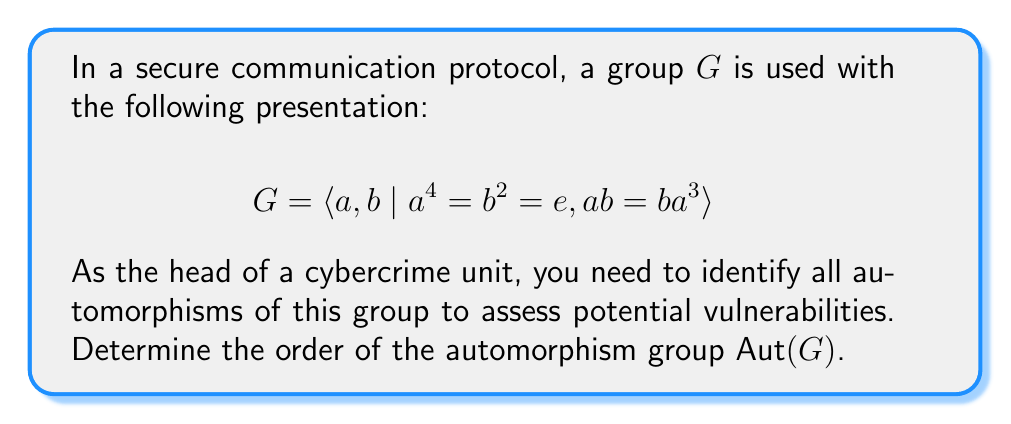Give your solution to this math problem. To solve this problem, we'll follow these steps:

1) First, we need to understand the structure of the group $G$. From the presentation, we can deduce that $G$ is a non-abelian group of order 8.

2) There are only two non-abelian groups of order 8: the dihedral group $D_4$ and the quaternion group $Q_8$. The given presentation matches that of $D_4$.

3) For $D_4$, we know that:
   - $a$ generates a cyclic subgroup of order 4
   - $b$ is an element of order 2
   - $ab$ has order 2

4) Any automorphism of $D_4$ must map $a$ to an element of order 4, and $b$ to an element of order 2.

5) The elements of order 4 in $D_4$ are $a$ and $a^3$.
   The elements of order 2 in $D_4$ are $a^2$, $b$, $ab$, and $a^3b$.

6) An automorphism is completely determined by where it sends $a$ and $b$. We have 2 choices for the image of $a$, and 3 choices for the image of $b$ (we can't map $b$ to $a^2$ as this wouldn't preserve the relation $ab = ba^3$).

7) Therefore, there are $2 \times 3 = 6$ possible automorphisms of $D_4$.

8) We can verify that these 6 mappings indeed form a group under composition, which is isomorphic to $S_3$, the symmetric group on 3 elements.

Thus, $|\text{Aut}(G)| = |\text{Aut}(D_4)| = |S_3| = 6$.
Answer: The order of the automorphism group $\text{Aut}(G)$ is 6. 